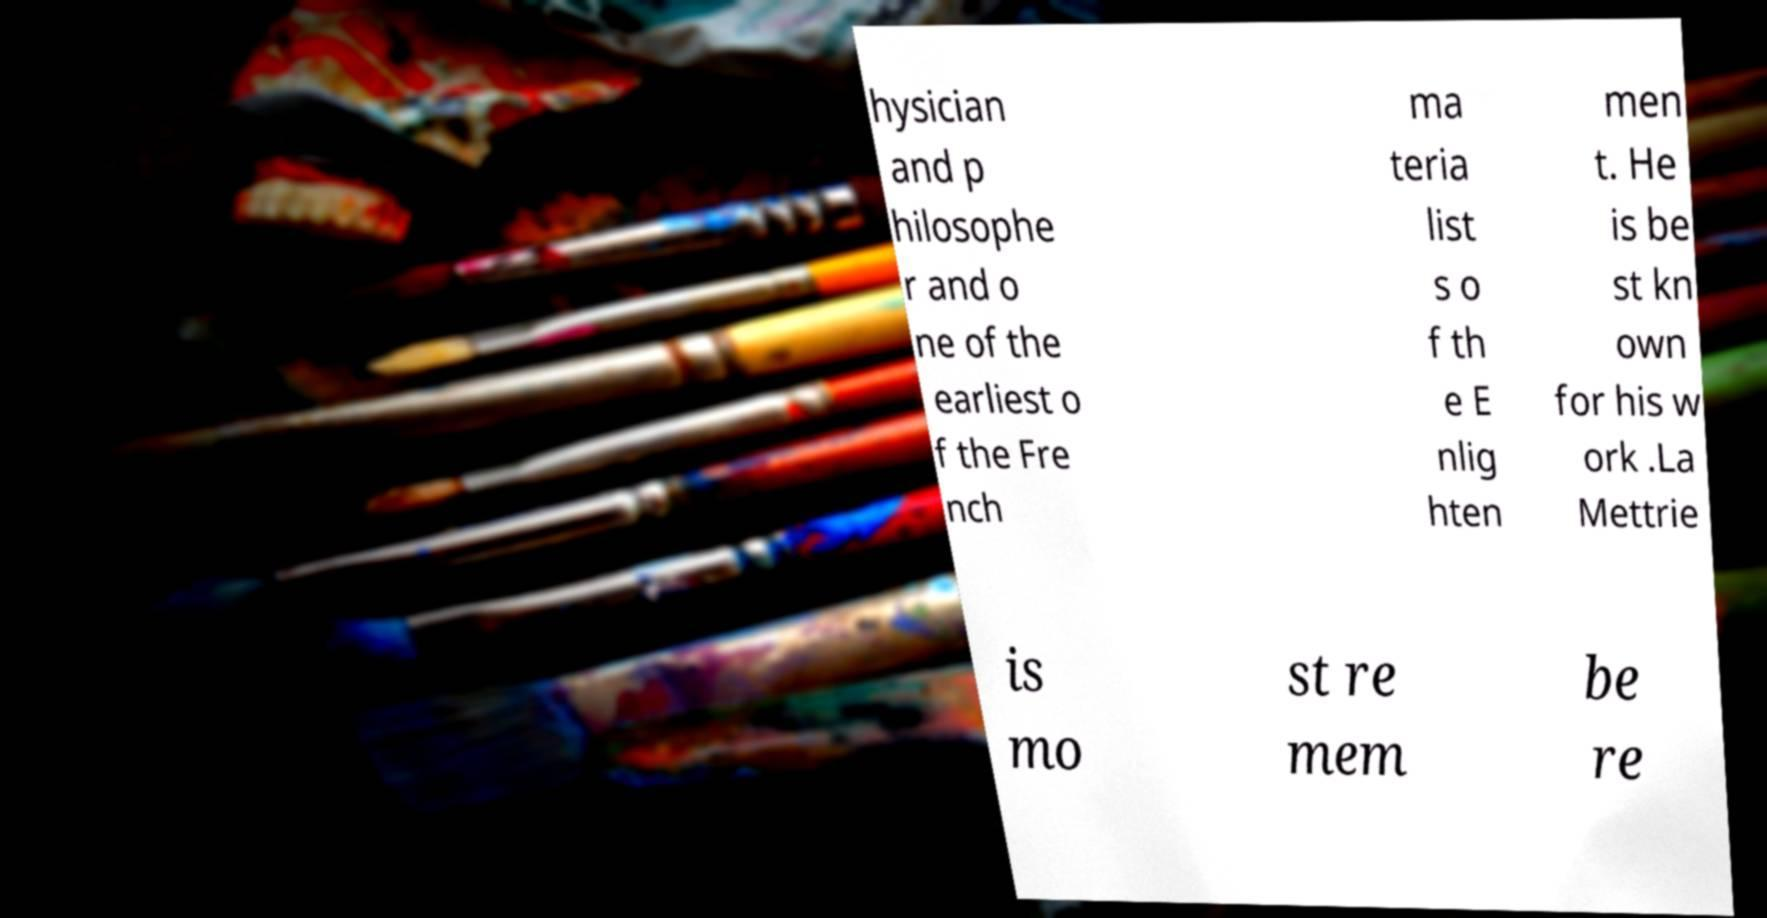Could you assist in decoding the text presented in this image and type it out clearly? hysician and p hilosophe r and o ne of the earliest o f the Fre nch ma teria list s o f th e E nlig hten men t. He is be st kn own for his w ork .La Mettrie is mo st re mem be re 